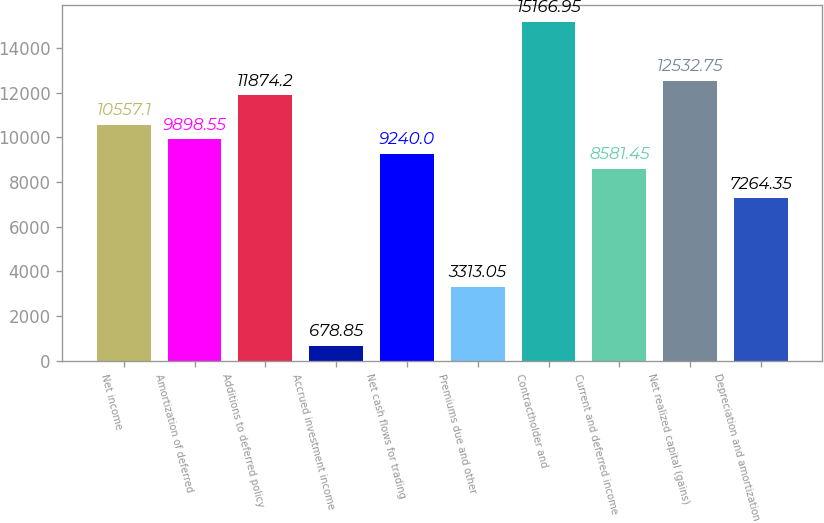Convert chart to OTSL. <chart><loc_0><loc_0><loc_500><loc_500><bar_chart><fcel>Net income<fcel>Amortization of deferred<fcel>Additions to deferred policy<fcel>Accrued investment income<fcel>Net cash flows for trading<fcel>Premiums due and other<fcel>Contractholder and<fcel>Current and deferred income<fcel>Net realized capital (gains)<fcel>Depreciation and amortization<nl><fcel>10557.1<fcel>9898.55<fcel>11874.2<fcel>678.85<fcel>9240<fcel>3313.05<fcel>15167<fcel>8581.45<fcel>12532.8<fcel>7264.35<nl></chart> 